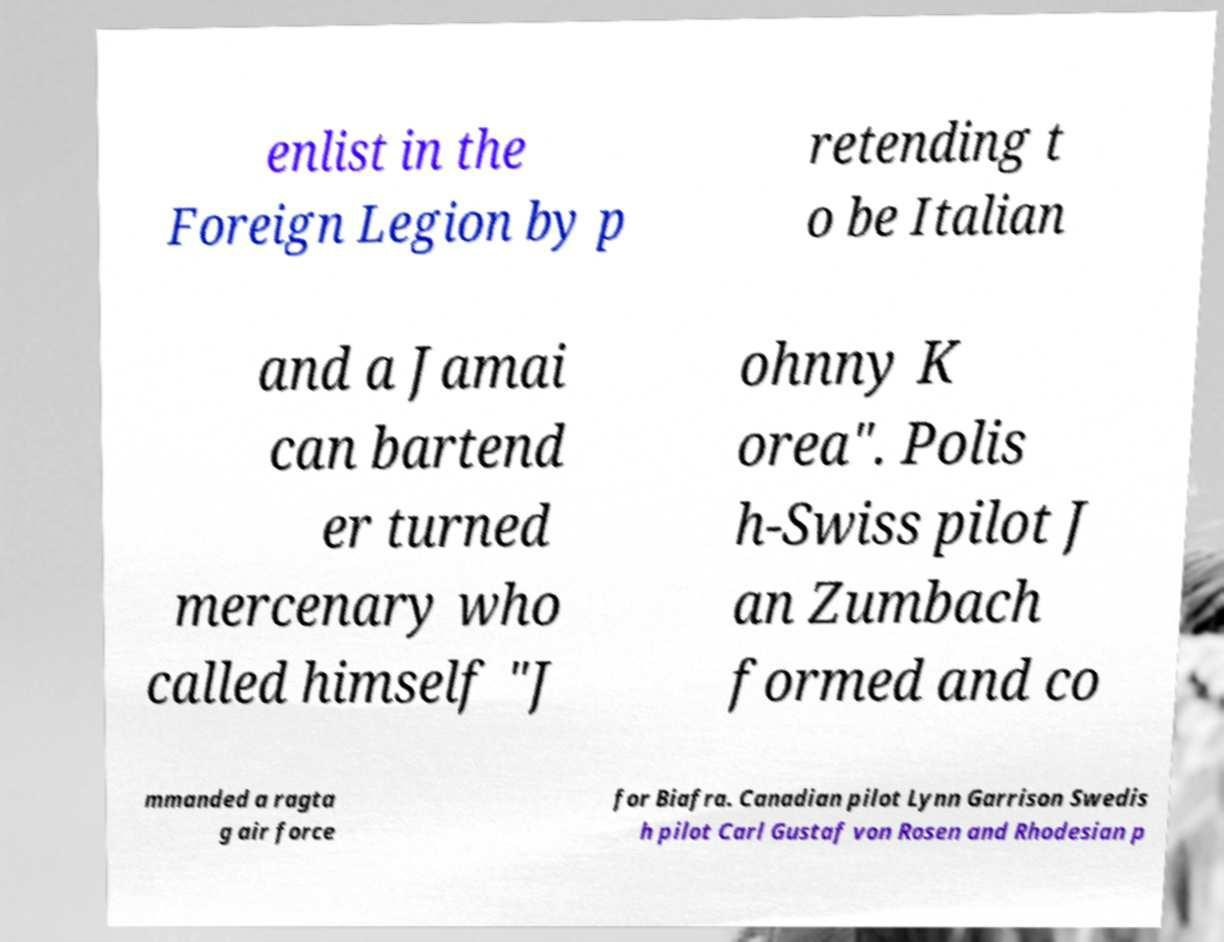Could you assist in decoding the text presented in this image and type it out clearly? enlist in the Foreign Legion by p retending t o be Italian and a Jamai can bartend er turned mercenary who called himself "J ohnny K orea". Polis h-Swiss pilot J an Zumbach formed and co mmanded a ragta g air force for Biafra. Canadian pilot Lynn Garrison Swedis h pilot Carl Gustaf von Rosen and Rhodesian p 